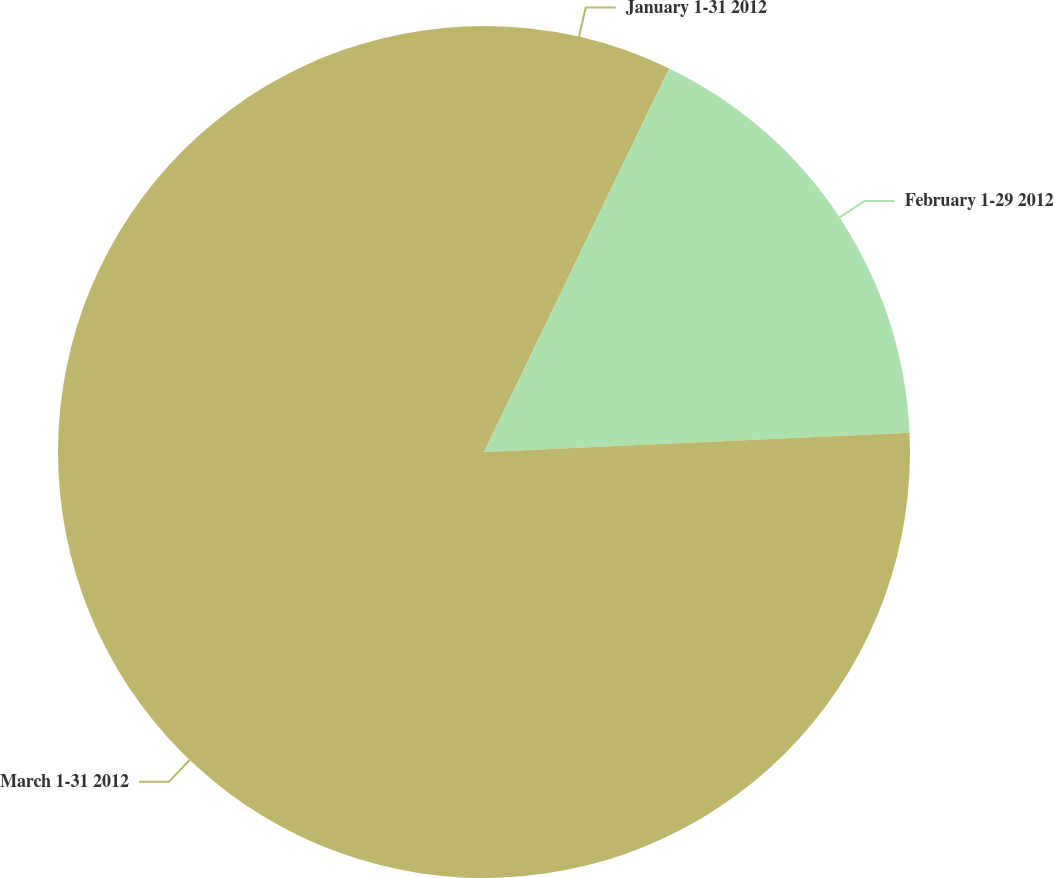Convert chart to OTSL. <chart><loc_0><loc_0><loc_500><loc_500><pie_chart><fcel>January 1-31 2012<fcel>February 1-29 2012<fcel>March 1-31 2012<nl><fcel>7.16%<fcel>17.12%<fcel>75.73%<nl></chart> 